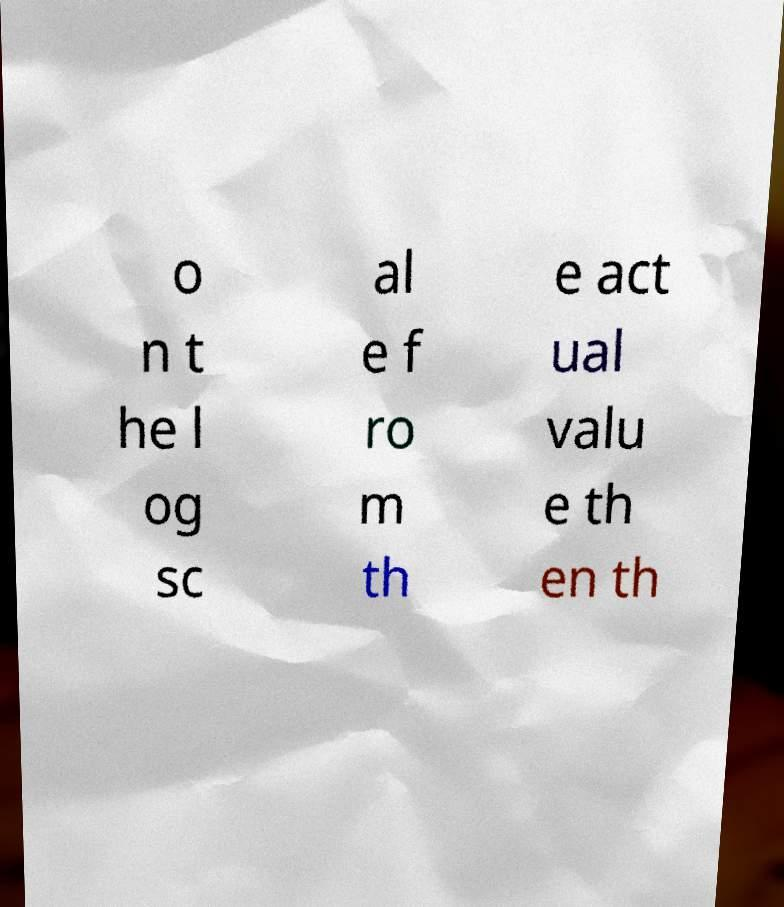For documentation purposes, I need the text within this image transcribed. Could you provide that? o n t he l og sc al e f ro m th e act ual valu e th en th 